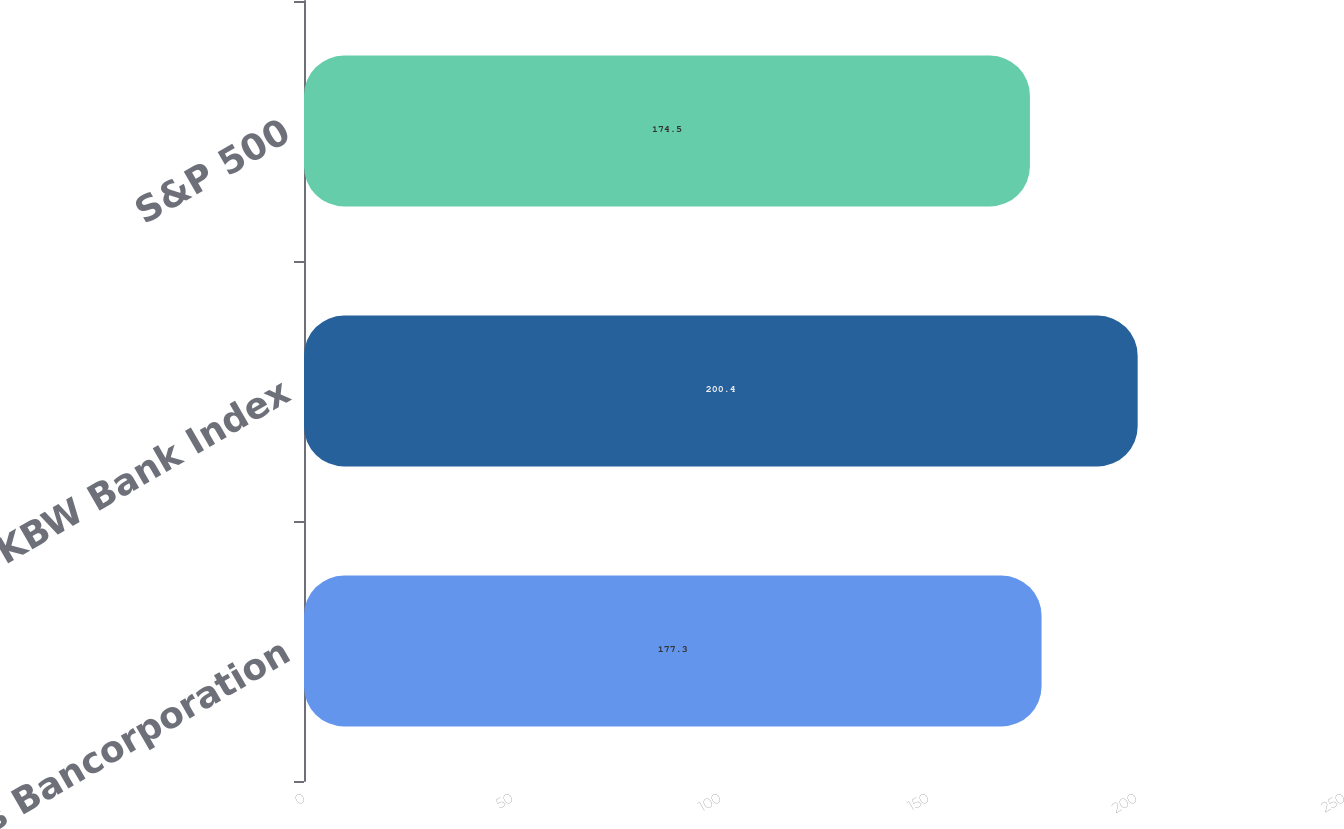<chart> <loc_0><loc_0><loc_500><loc_500><bar_chart><fcel>Zions Bancorporation<fcel>KBW Bank Index<fcel>S&P 500<nl><fcel>177.3<fcel>200.4<fcel>174.5<nl></chart> 